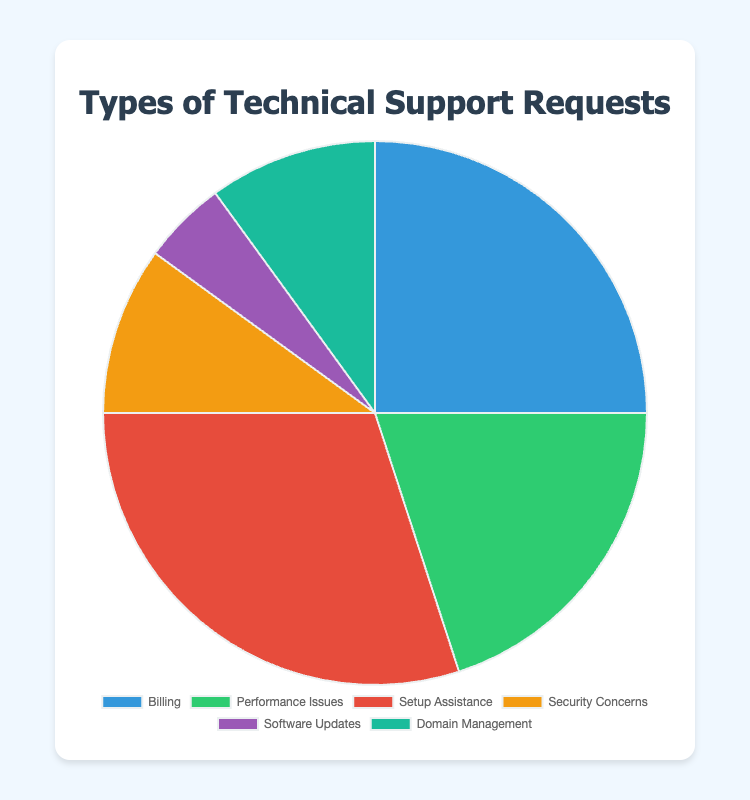What percentage of technical support requests are related to Setup Assistance? The pie chart shows six types of technical support requests, and each type has a percentage labeled. For Setup Assistance, the percentage shown is 30%.
Answer: 30% Which type of technical support request accounts for the smallest percentage? By visually inspecting the pie chart, we can see that Software Updates has the smallest colored section. The percentage for Software Updates is 5%, which is the lowest among all categories.
Answer: Software Updates How do the percentages for Billing and Performance Issues compare to each other? In the pie chart, Billing is labeled with a percentage of 25%, and Performance Issues is labeled with a percentage of 20%. Since 25% is larger than 20%, Billing accounts for a higher percentage of requests compared to Performance Issues.
Answer: Billing has a higher percentage than Performance Issues What are the combined percentages for Security Concerns and Domain Management? The pie chart shows Security Concerns with a percentage of 10% and Domain Management with 10%. Adding these together: 10% + 10% = 20%.
Answer: 20% What is the difference in percentage points between Setup Assistance and Performance Issues? Setup Assistance has a percentage of 30%, and Performance Issues has a percentage of 20%. The difference is 30% - 20% = 10 percentage points.
Answer: 10 percentage points Which category of technical support request is represented by the purple color? By visually inspecting the pie chart and matching the colors to the labels, the purple section corresponds to Software Updates, which is labeled with a 5% share.
Answer: Software Updates How many types of technical support requests have percentages below 20%? From the pie chart, Software Updates has 5%, Security Concerns has 10%, and Domain Management also has 10%. These are all below 20%. Counting these, we get three types: Software Updates, Security Concerns, and Domain Management.
Answer: Three types Which type of request forms a larger percentage: Security Concerns or Domain Management? Both Security Concerns and Domain Management are labeled with a 10% share each. Since they have equal percentages, neither is larger than the other.
Answer: Both are equal 